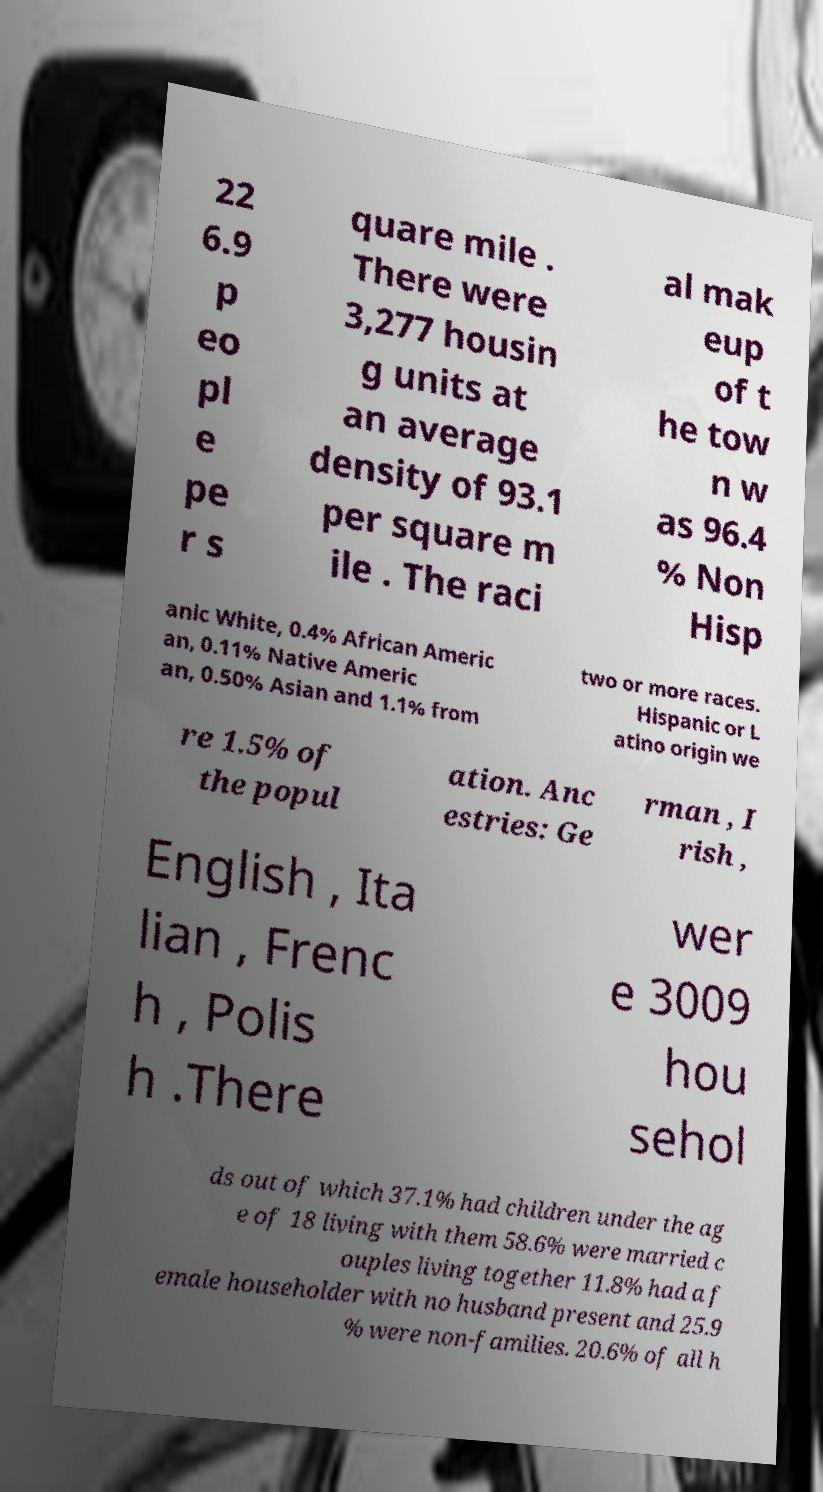Please identify and transcribe the text found in this image. 22 6.9 p eo pl e pe r s quare mile . There were 3,277 housin g units at an average density of 93.1 per square m ile . The raci al mak eup of t he tow n w as 96.4 % Non Hisp anic White, 0.4% African Americ an, 0.11% Native Americ an, 0.50% Asian and 1.1% from two or more races. Hispanic or L atino origin we re 1.5% of the popul ation. Anc estries: Ge rman , I rish , English , Ita lian , Frenc h , Polis h .There wer e 3009 hou sehol ds out of which 37.1% had children under the ag e of 18 living with them 58.6% were married c ouples living together 11.8% had a f emale householder with no husband present and 25.9 % were non-families. 20.6% of all h 